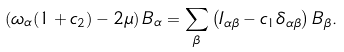Convert formula to latex. <formula><loc_0><loc_0><loc_500><loc_500>\left ( \omega _ { \alpha } ( 1 + c _ { 2 } ) - 2 \mu \right ) B _ { \alpha } = \sum _ { \beta } \left ( I _ { \alpha \beta } - c _ { 1 } \delta _ { \alpha \beta } \right ) B _ { \beta } .</formula> 